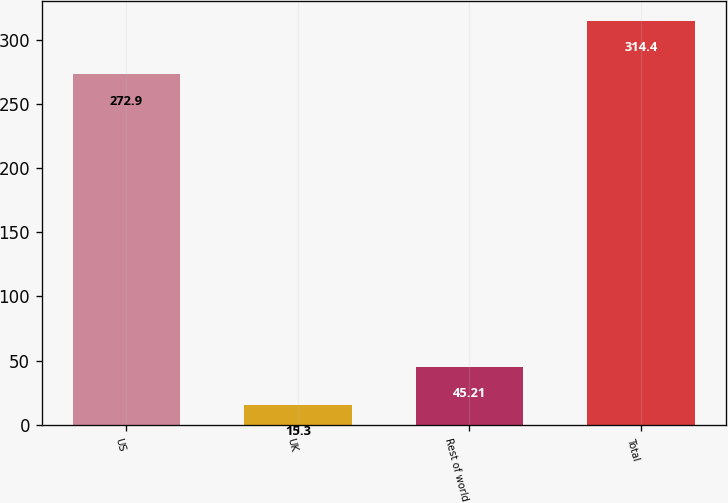<chart> <loc_0><loc_0><loc_500><loc_500><bar_chart><fcel>US<fcel>UK<fcel>Rest of world<fcel>Total<nl><fcel>272.9<fcel>15.3<fcel>45.21<fcel>314.4<nl></chart> 